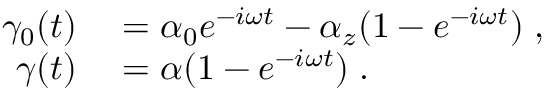Convert formula to latex. <formula><loc_0><loc_0><loc_500><loc_500>\begin{array} { r l } { \gamma _ { 0 } ( t ) } & = \alpha _ { 0 } e ^ { - i \omega t } - \alpha _ { z } ( 1 - e ^ { - i \omega t } ) \, , } \\ { \gamma ( t ) } & = \alpha ( 1 - e ^ { - i \omega t } ) \, . } \end{array}</formula> 